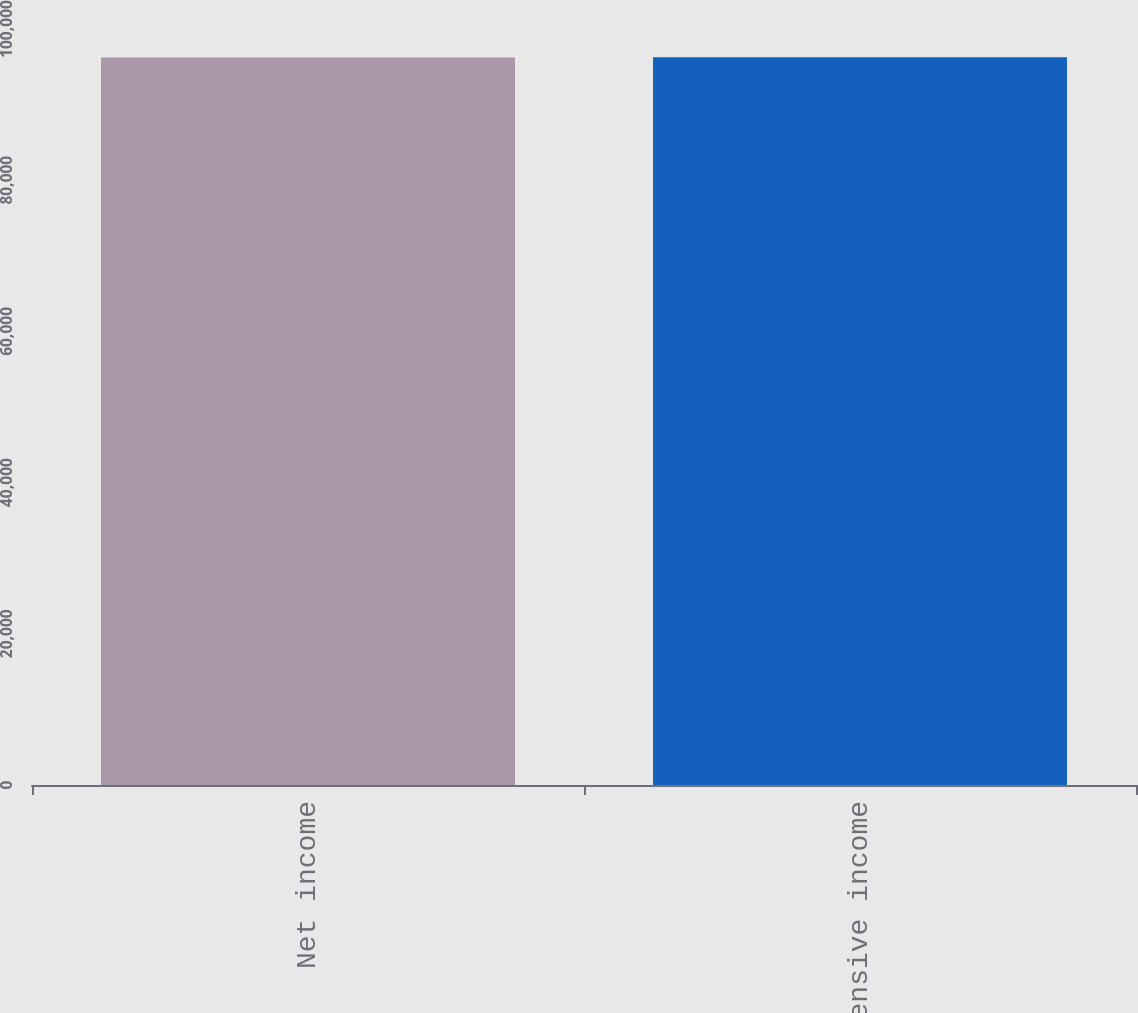Convert chart to OTSL. <chart><loc_0><loc_0><loc_500><loc_500><bar_chart><fcel>Net income<fcel>Comprehensive income<nl><fcel>96241<fcel>96263<nl></chart> 